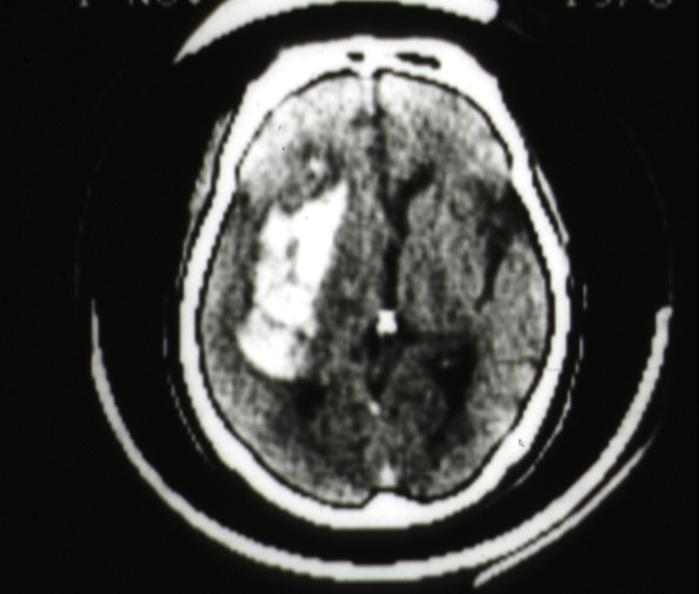does cat scan hemorrhage in putamen area?
Answer the question using a single word or phrase. Yes 